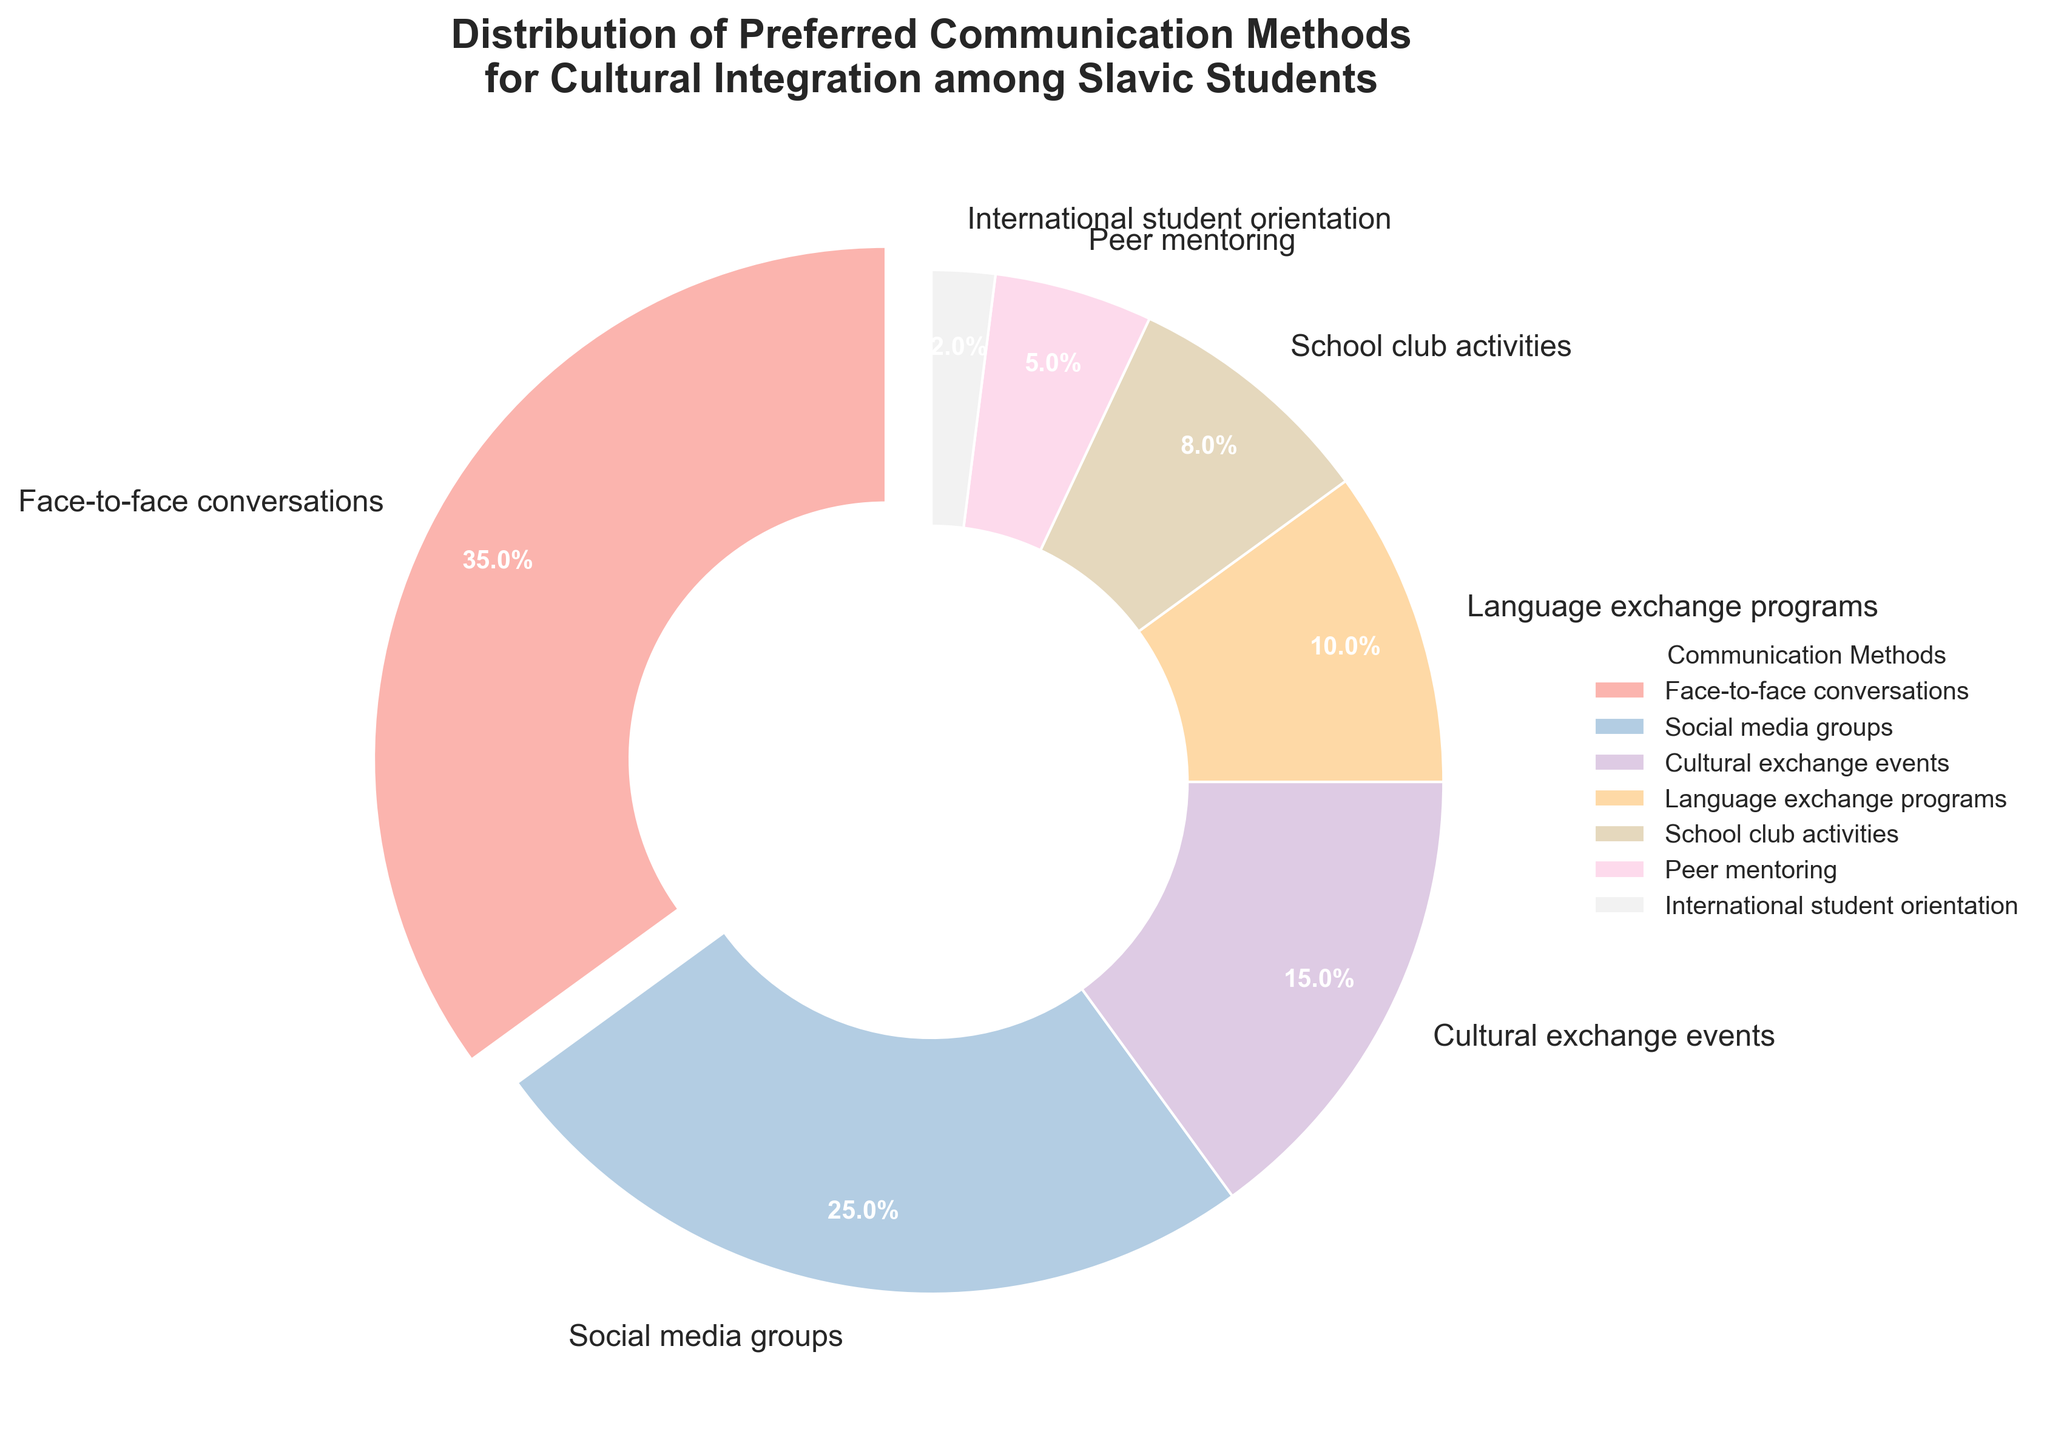Which communication method is preferred by the highest percentage of Slavic students? The figure shows a pie chart with various communication methods and their corresponding percentages. The segment with the highest percentage (35%) is for face-to-face conversations.
Answer: Face-to-face conversations Which two methods together constitute half of the total preferences? Summing the two highest percentages: 35% (Face-to-face conversations) and 25% (Social media groups), gives us 60%, which is more than half. Let's check the next combination: 35% (Face-to-face conversations) and 15% (Cultural exchange events), which gives us 50%.
Answer: Face-to-face conversations and Cultural exchange events How much more popular are social media groups compared to peer mentoring? Social media groups have a percentage of 25%, while peer mentoring has 5%. The difference is 25% - 5%.
Answer: 20% Which method has the smallest percentage? The figure shows the percentages for various methods, and the segment with the smallest percentage (2%) is for international student orientation.
Answer: International student orientation Combine the percentages of methods preferred by at least 10% of Slavic students. Adding the percentages of methods preferred by at least 10% (Face-to-face conversations: 35%, Social media groups: 25%, Cultural exchange events: 15%, Language exchange programs: 10%) gives us 35% + 25% + 15% + 10%.
Answer: 85% Are cultural exchange events more or less popular than school club activities? The figure shows cultural exchange events have 15%, while school club activities have 8%. So, cultural exchange events are more popular.
Answer: More popular Identify the method represented by the slice that is visually most distinct from others. The slice that is visually distinct is the one slightly separated from the rest. According to the pie chart, this method is face-to-face conversations.
Answer: Face-to-face conversations Arrange the methods in descending order of preference. Arranging the percentages in descending order, we get: Face-to-face conversations (35%), Social media groups (25%), Cultural exchange events (15%), Language exchange programs (10%), School club activities (8%), Peer mentoring (5%), International student orientation (2%).
Answer: Face-to-face conversations, Social media groups, Cultural exchange events, Language exchange programs, School club activities, Peer mentoring, International student orientation Which methods combined account for a preference percentage equal to or greater than that of face-to-face conversations? The face-to-face conversations have 35%. Combining other methods, we get 25% (Social media groups) + 10% (Language exchange programs) = 35%, or alternatively, 15% (Cultural exchange events) + 10% (Language exchange programs) + 10% (School club activities) = 35%.
Answer: Social media groups and Language exchange programs or Cultural exchange events, Language exchange programs, and School club activities Which segment has the largest allocated width on the pie chart? The pie chart visually allocates width based on the percentage, so the segment for face-to-face conversations, which has the highest percentage (35%), will have the largest width.
Answer: Face-to-face conversations 